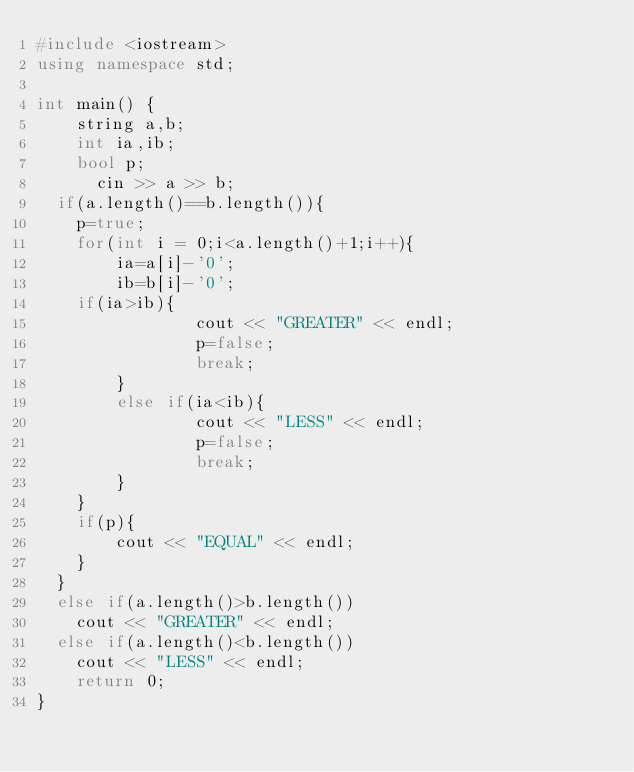Convert code to text. <code><loc_0><loc_0><loc_500><loc_500><_C++_>#include <iostream>
using namespace std;
 
int main() {
	string a,b;
	int ia,ib;
	bool p;
      cin >> a >> b;
  if(a.length()==b.length()){
  	p=true;
	for(int i = 0;i<a.length()+1;i++){
  		ia=a[i]-'0';
  		ib=b[i]-'0';
	if(ia>ib){
    			cout << "GREATER" << endl;
    			p=false;
    			break;
		}
		else if(ia<ib){
    			cout << "LESS" << endl;
    			p=false;
    			break;
		}
	}
	if(p){
		cout << "EQUAL" << endl;
	}
  }
  else if(a.length()>b.length())
    cout << "GREATER" << endl;
  else if(a.length()<b.length())
    cout << "LESS" << endl;
	return 0;
}</code> 